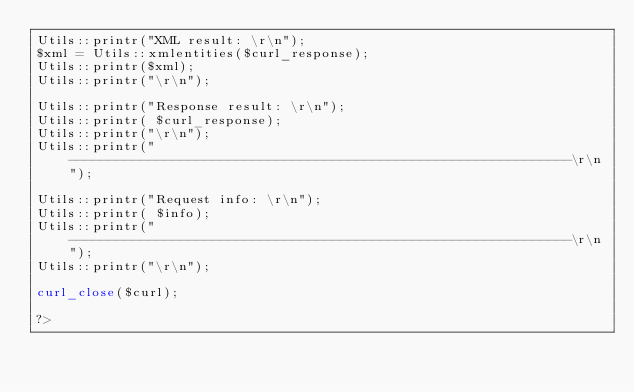<code> <loc_0><loc_0><loc_500><loc_500><_PHP_>Utils::printr("XML result: \r\n");
$xml = Utils::xmlentities($curl_response); 
Utils::printr($xml);
Utils::printr("\r\n");

Utils::printr("Response result: \r\n");
Utils::printr( $curl_response);
Utils::printr("\r\n");
Utils::printr("---------------------------------------------------------------\r\n");

Utils::printr("Request info: \r\n");
Utils::printr( $info);
Utils::printr("---------------------------------------------------------------\r\n");
Utils::printr("\r\n");

curl_close($curl);

?>

</code> 